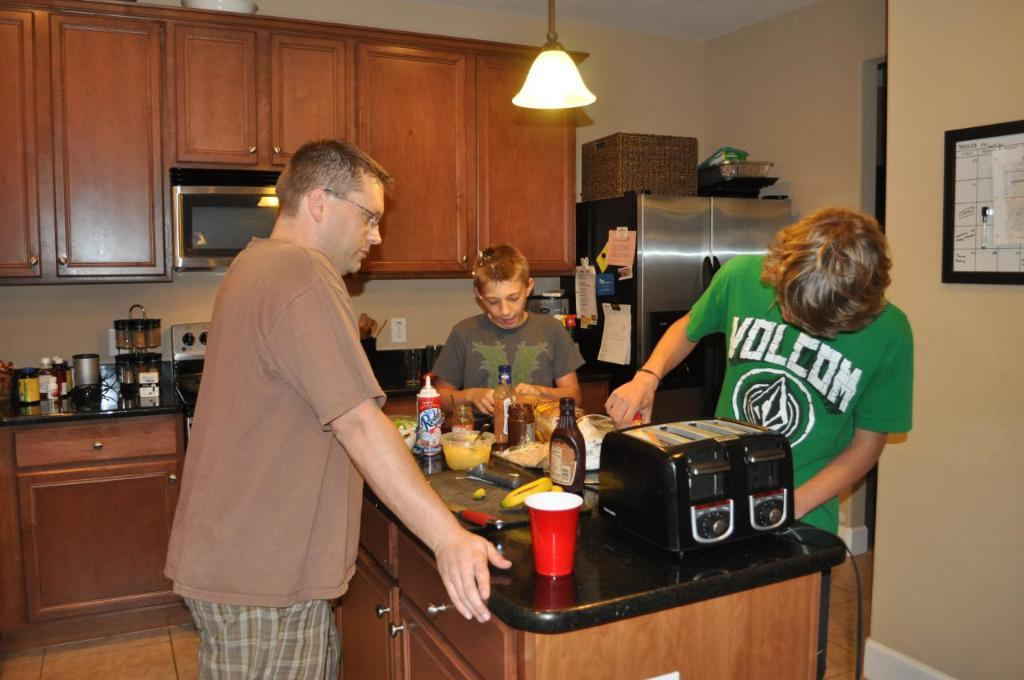<image>
Provide a brief description of the given image. Three people, including one wearing a green Volcom shirt, stand at a counter. 